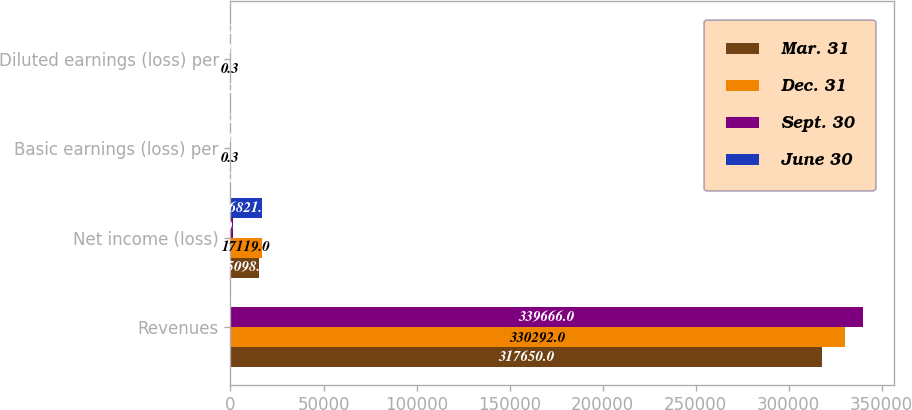Convert chart. <chart><loc_0><loc_0><loc_500><loc_500><stacked_bar_chart><ecel><fcel>Revenues<fcel>Net income (loss)<fcel>Basic earnings (loss) per<fcel>Diluted earnings (loss) per<nl><fcel>Mar. 31<fcel>317650<fcel>15098<fcel>0.26<fcel>0.26<nl><fcel>Dec. 31<fcel>330292<fcel>17119<fcel>0.3<fcel>0.3<nl><fcel>Sept. 30<fcel>339666<fcel>1190<fcel>0.02<fcel>0.02<nl><fcel>June 30<fcel>0.3<fcel>16821<fcel>0.29<fcel>0.29<nl></chart> 